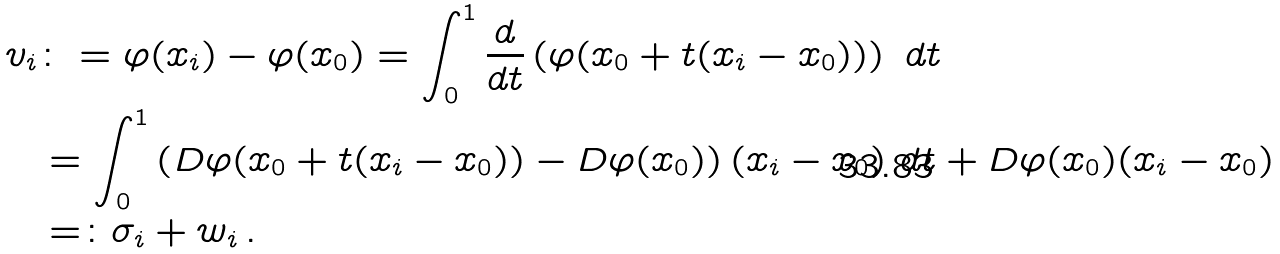Convert formula to latex. <formula><loc_0><loc_0><loc_500><loc_500>v _ { i } & \colon = \varphi ( x _ { i } ) - \varphi ( x _ { 0 } ) = \int _ { 0 } ^ { 1 } \frac { d } { d t } \left ( \varphi ( x _ { 0 } + t ( x _ { i } - x _ { 0 } ) ) \right ) \ d t \\ & = \int _ { 0 } ^ { 1 } \left ( D \varphi ( x _ { 0 } + t ( x _ { i } - x _ { 0 } ) ) - D \varphi ( x _ { 0 } ) \right ) ( x _ { i } - x _ { 0 } ) \ d t + D \varphi ( x _ { 0 } ) ( x _ { i } - x _ { 0 } ) \\ & = \colon \sigma _ { i } + w _ { i } \, .</formula> 